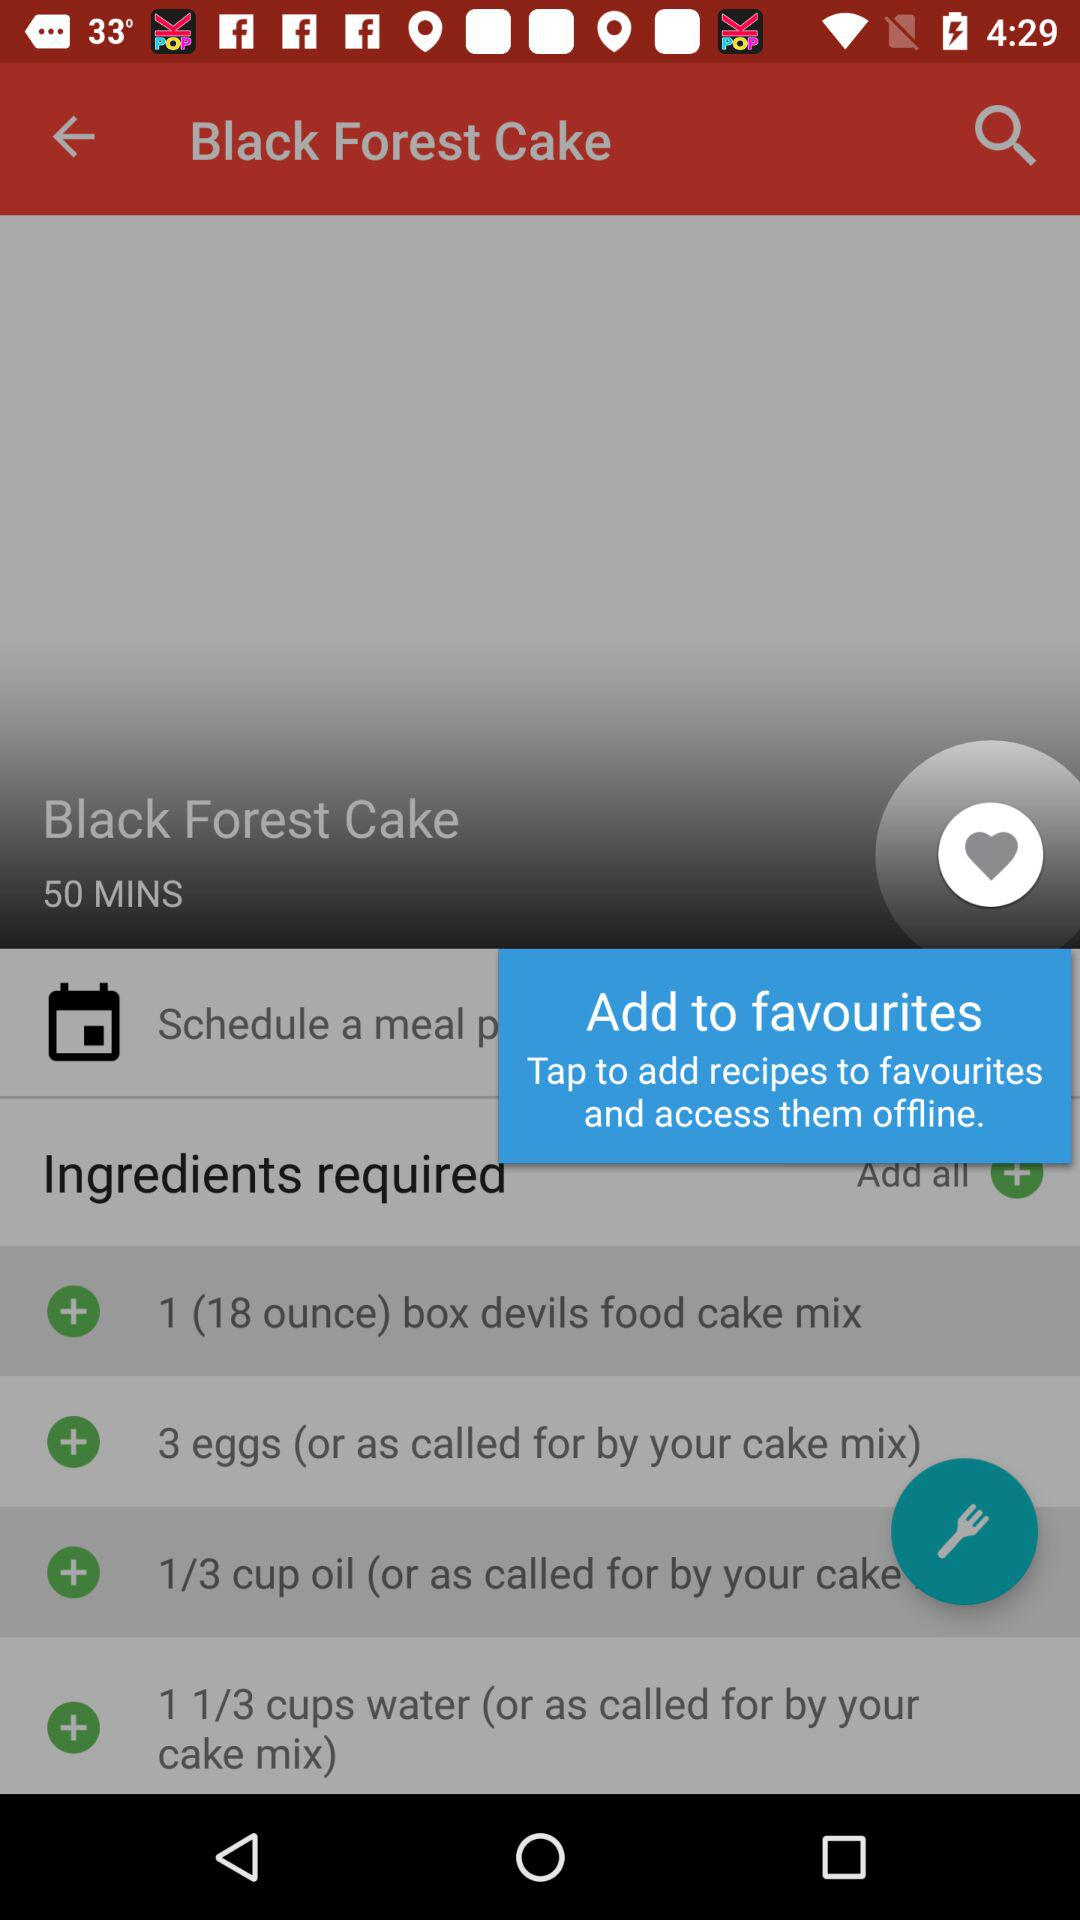What are the different ingredients required to prepare the Black Forest Cake? The different ingredients are 1 (18 ounce) box of devils food cake mix, 3 eggs (or as called for by your cake mix), 1/3 cup oil (or as called for by your cake mix) and 1 1/3 cups water (or as called for by your cake mix). 